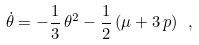<formula> <loc_0><loc_0><loc_500><loc_500>\dot { \theta } = - \frac { 1 } { 3 } \, \theta ^ { 2 } - \frac { 1 } { 2 } \, ( \mu + 3 \, p ) \ ,</formula> 